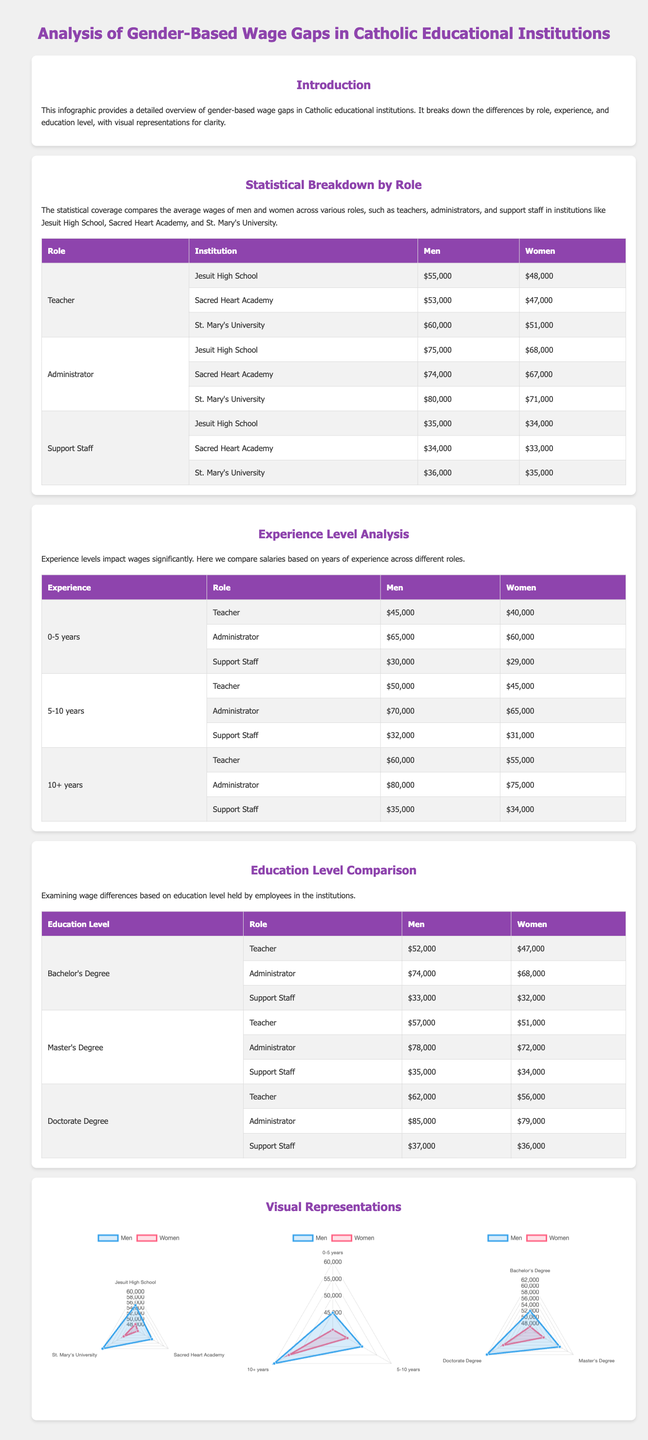What is the highest average salary for men in Catholic educational institutions? The highest average salary for men in the document is found in the Administrator role at St. Mary's University, which is $80,000.
Answer: $80,000 What is the wage gap for teachers at Jesuit High School? The wage gap for teachers at Jesuit High School can be calculated by subtracting the women's salary from men's salary, which is $55,000 - $48,000 = $7,000.
Answer: $7,000 Which institution has the lowest average salary for women in the Support Staff role? The lowest average salary for women in the Support Staff role is at Sacred Heart Academy, where it is $33,000.
Answer: $33,000 What is the average salary for women with a Doctorate Degree in Catholic educational institutions? The average salary for women with a Doctorate Degree across all roles in the document is $56,000.
Answer: $56,000 How much do men earn on average in the Administrator role with 10+ years of experience? The average salary for men in the Administrator role with 10+ years of experience is $80,000 as stated in the document.
Answer: $80,000 Which educational qualification yields the highest average salary for men in the Administrator role? The highest average salary for men in the Administrator role is for those holding a Doctorate Degree at $85,000.
Answer: $85,000 In the experience level analysis, what is the salary difference for teachers between 0-5 years of experience and 10+ years? The salary difference can be calculated as $60,000 (10+ years) - $45,000 (0-5 years) = $15,000.
Answer: $15,000 How many institutions are compared in the role analysis? The document compares three institutions: Jesuit High School, Sacred Heart Academy, and St. Mary's University.
Answer: Three What type of chart is used to represent the wage comparisons in the document? The type of chart used in the document for representing wage comparisons is a radar chart, as mentioned in the visual representations section.
Answer: Radar chart 